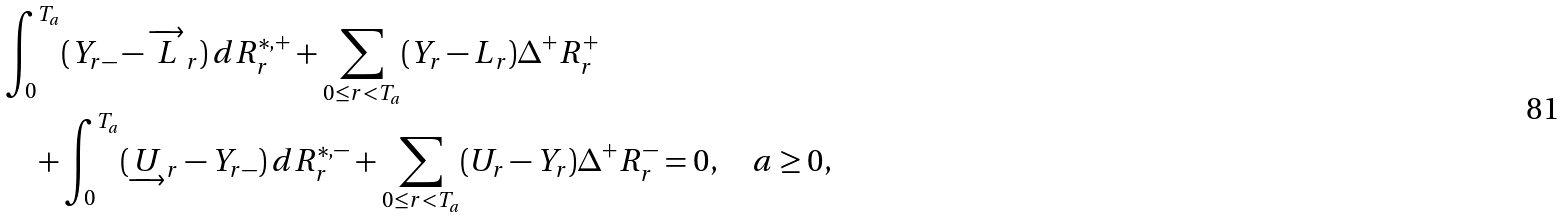<formula> <loc_0><loc_0><loc_500><loc_500>& \int ^ { T _ { a } } _ { 0 } ( Y _ { r - } - \overrightarrow { L } _ { r } ) \, d R ^ { * , + } _ { r } + \sum _ { 0 \leq r < T _ { a } } ( Y _ { r } - L _ { r } ) \Delta ^ { + } R ^ { + } _ { r } \\ & \quad + \int ^ { T _ { a } } _ { 0 } ( \underrightarrow { U } _ { r } - Y _ { r - } ) \, d R ^ { * , - } _ { r } + \sum _ { 0 \leq r < T _ { a } } ( U _ { r } - Y _ { r } ) \Delta ^ { + } R ^ { - } _ { r } = 0 , \quad a \geq 0 ,</formula> 